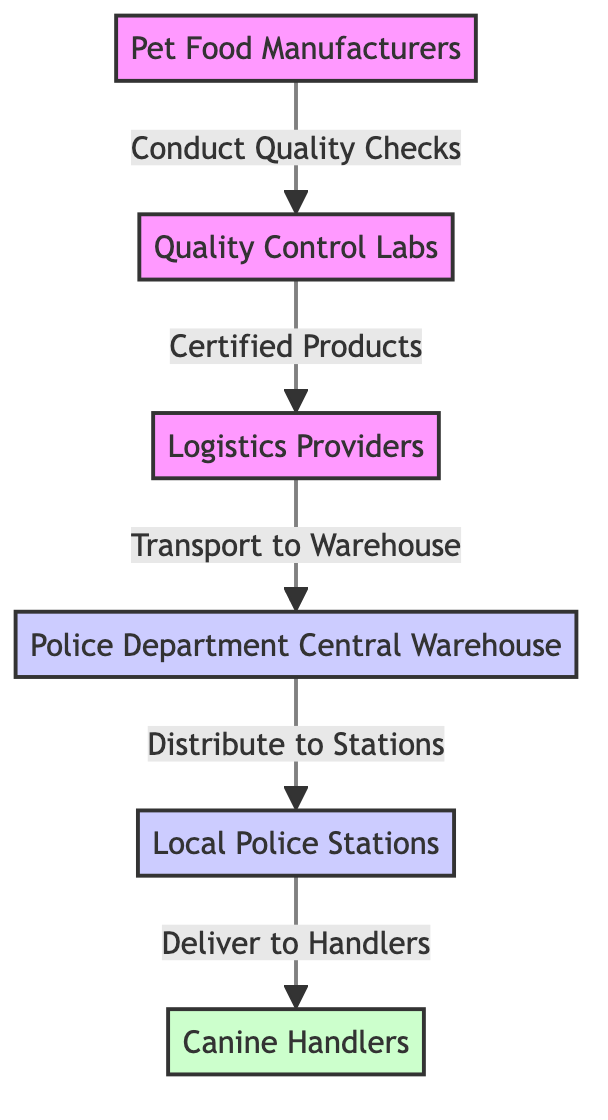What is the first step in this supply chain? The first step, as shown in the diagram, is the node "Pet Food Manufacturers." It is the starting point from which the process flows.
Answer: Pet Food Manufacturers Which node receives certified products? The node that directly receives certified products is "Logistics Providers," which comes after "Quality Control Labs."
Answer: Logistics Providers How many nodes are in the diagram? By counting the distinct nodes in the diagram—Pet Food Manufacturers, Quality Control Labs, Logistics Providers, Police Department Central Warehouse, Local Police Stations, and Canine Handlers—we find there are 6 nodes in total.
Answer: 6 What type of relationship is shown between "Quality Control Labs" and "Logistics Providers"? The relationship depicted is a one-way flow labeled "Certified Products," indicating that certified products flow from Quality Control Labs to Logistics Providers.
Answer: Certified Products Which node is classified as 'warehouse'? The node classified as 'warehouse' is "Police Department Central Warehouse," which is explicitly labeled in the diagram.
Answer: Police Department Central Warehouse How do products reach the "Canine Handlers"? Products reach the "Canine Handlers" through the following steps: first, they are distributed from "Police Department Central Warehouse" to "Local Police Stations," and then delivered from "Local Police Stations" to "Canine Handlers." This is a two-step process involving these transitions.
Answer: Through distribution and delivery What is the final destination in this supply chain? The final destination in this supply chain, as shown in the diagram, is "Canine Handlers," marking the endpoint after the flow of products.
Answer: Canine Handlers 